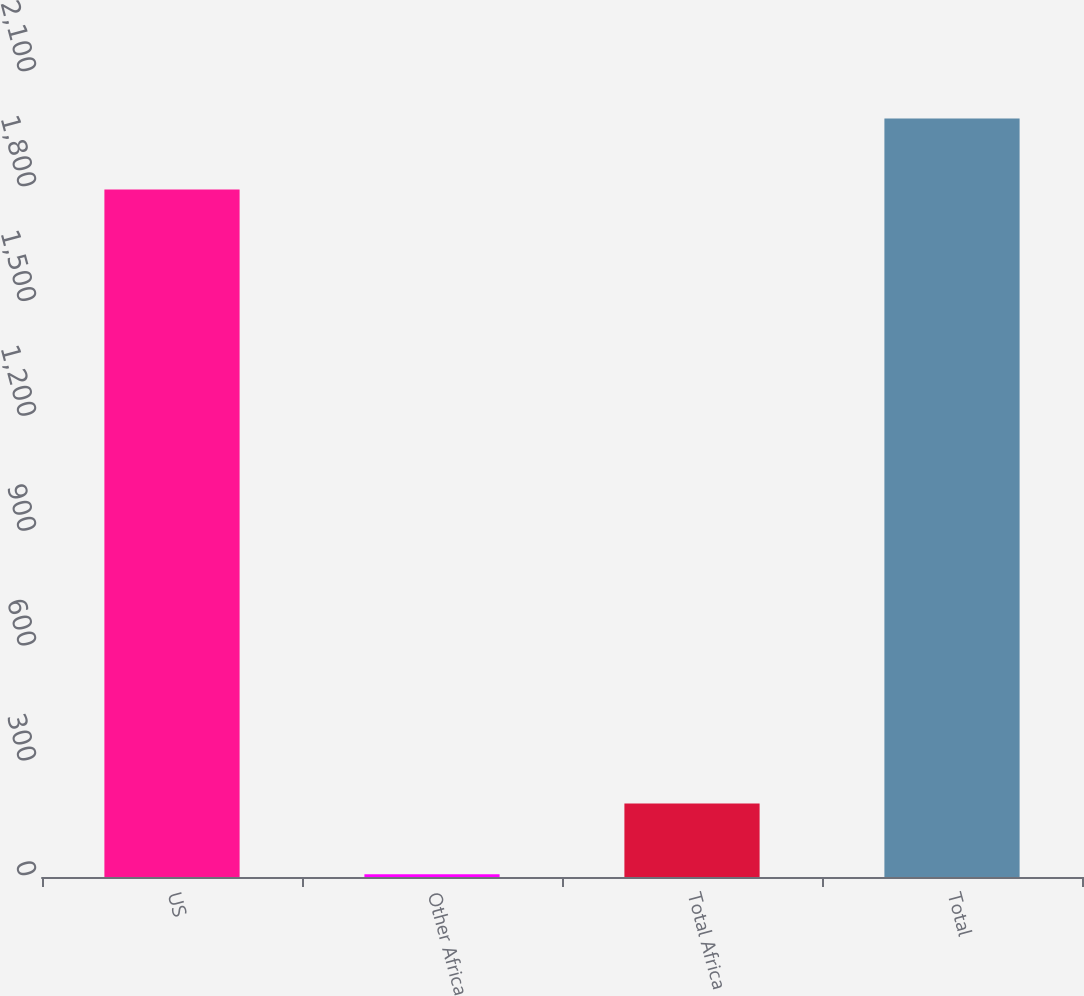<chart> <loc_0><loc_0><loc_500><loc_500><bar_chart><fcel>US<fcel>Other Africa<fcel>Total Africa<fcel>Total<nl><fcel>1796<fcel>7<fcel>192.2<fcel>1981.2<nl></chart> 